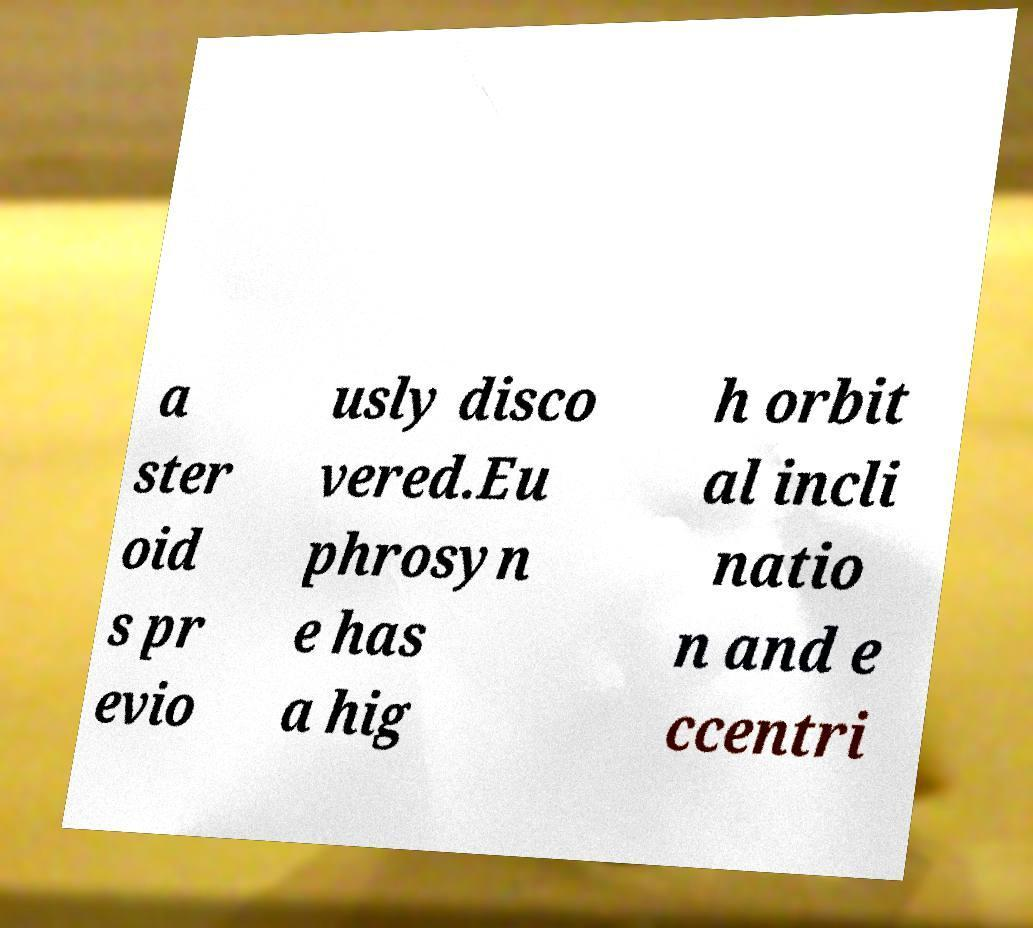Could you assist in decoding the text presented in this image and type it out clearly? a ster oid s pr evio usly disco vered.Eu phrosyn e has a hig h orbit al incli natio n and e ccentri 